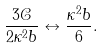<formula> <loc_0><loc_0><loc_500><loc_500>\frac { 3 \mathcal { C } } { 2 \kappa ^ { 2 } b } \leftrightarrow \frac { \kappa ^ { 2 } b } { 6 } .</formula> 